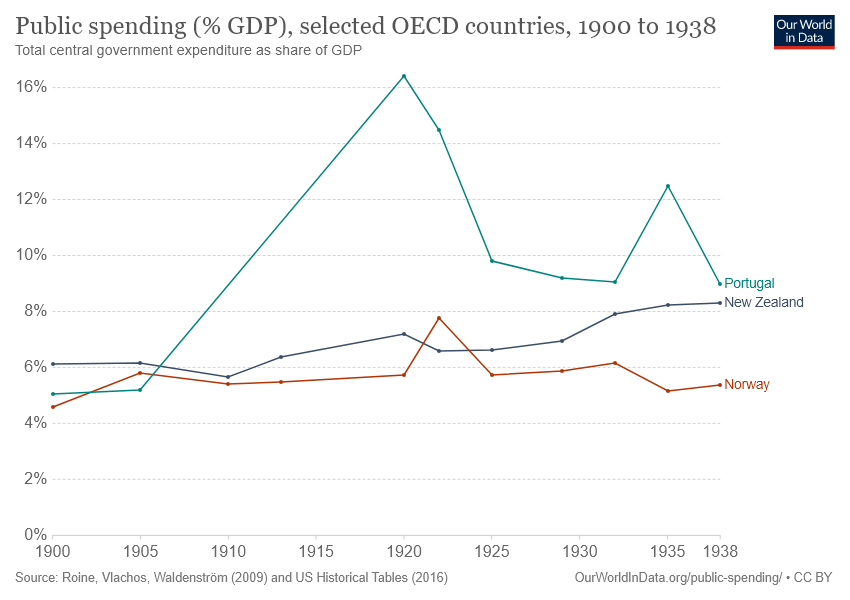Point out several critical features in this image. The chart includes 3 countries. New Zealand's public spending is not always higher than Norway's. 